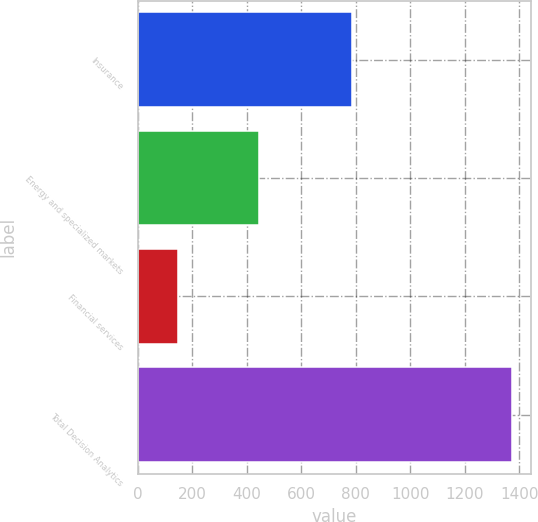Convert chart. <chart><loc_0><loc_0><loc_500><loc_500><bar_chart><fcel>Insurance<fcel>Energy and specialized markets<fcel>Financial services<fcel>Total Decision Analytics<nl><fcel>784.7<fcel>444.7<fcel>145.5<fcel>1374.9<nl></chart> 